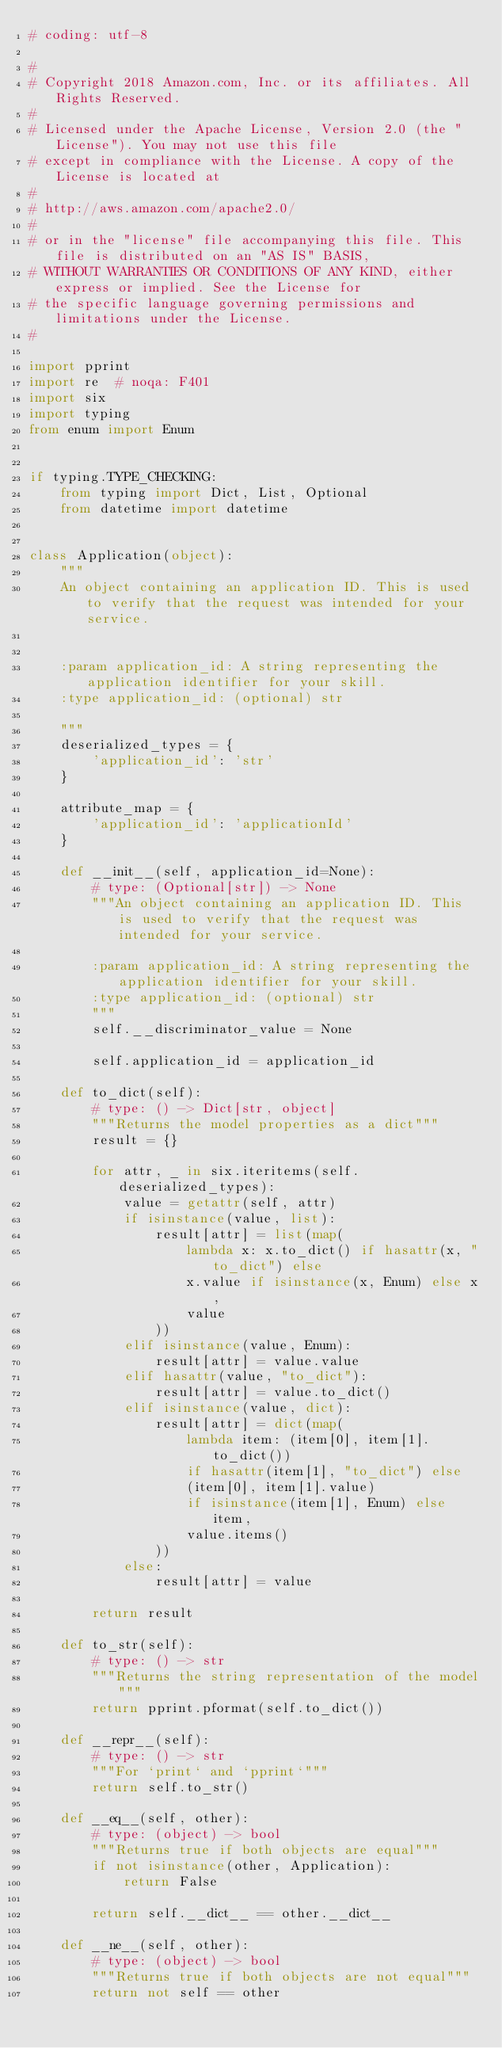Convert code to text. <code><loc_0><loc_0><loc_500><loc_500><_Python_># coding: utf-8

#
# Copyright 2018 Amazon.com, Inc. or its affiliates. All Rights Reserved.
#
# Licensed under the Apache License, Version 2.0 (the "License"). You may not use this file
# except in compliance with the License. A copy of the License is located at
#
# http://aws.amazon.com/apache2.0/
#
# or in the "license" file accompanying this file. This file is distributed on an "AS IS" BASIS,
# WITHOUT WARRANTIES OR CONDITIONS OF ANY KIND, either express or implied. See the License for
# the specific language governing permissions and limitations under the License.
#

import pprint
import re  # noqa: F401
import six
import typing
from enum import Enum


if typing.TYPE_CHECKING:
    from typing import Dict, List, Optional
    from datetime import datetime


class Application(object):
    """
    An object containing an application ID. This is used to verify that the request was intended for your service.


    :param application_id: A string representing the application identifier for your skill.
    :type application_id: (optional) str

    """
    deserialized_types = {
        'application_id': 'str'
    }

    attribute_map = {
        'application_id': 'applicationId'
    }

    def __init__(self, application_id=None):
        # type: (Optional[str]) -> None
        """An object containing an application ID. This is used to verify that the request was intended for your service.

        :param application_id: A string representing the application identifier for your skill.
        :type application_id: (optional) str
        """
        self.__discriminator_value = None

        self.application_id = application_id

    def to_dict(self):
        # type: () -> Dict[str, object]
        """Returns the model properties as a dict"""
        result = {}

        for attr, _ in six.iteritems(self.deserialized_types):
            value = getattr(self, attr)
            if isinstance(value, list):
                result[attr] = list(map(
                    lambda x: x.to_dict() if hasattr(x, "to_dict") else
                    x.value if isinstance(x, Enum) else x,
                    value
                ))
            elif isinstance(value, Enum):
                result[attr] = value.value
            elif hasattr(value, "to_dict"):
                result[attr] = value.to_dict()
            elif isinstance(value, dict):
                result[attr] = dict(map(
                    lambda item: (item[0], item[1].to_dict())
                    if hasattr(item[1], "to_dict") else
                    (item[0], item[1].value)
                    if isinstance(item[1], Enum) else item,
                    value.items()
                ))
            else:
                result[attr] = value

        return result

    def to_str(self):
        # type: () -> str
        """Returns the string representation of the model"""
        return pprint.pformat(self.to_dict())

    def __repr__(self):
        # type: () -> str
        """For `print` and `pprint`"""
        return self.to_str()

    def __eq__(self, other):
        # type: (object) -> bool
        """Returns true if both objects are equal"""
        if not isinstance(other, Application):
            return False

        return self.__dict__ == other.__dict__

    def __ne__(self, other):
        # type: (object) -> bool
        """Returns true if both objects are not equal"""
        return not self == other
</code> 